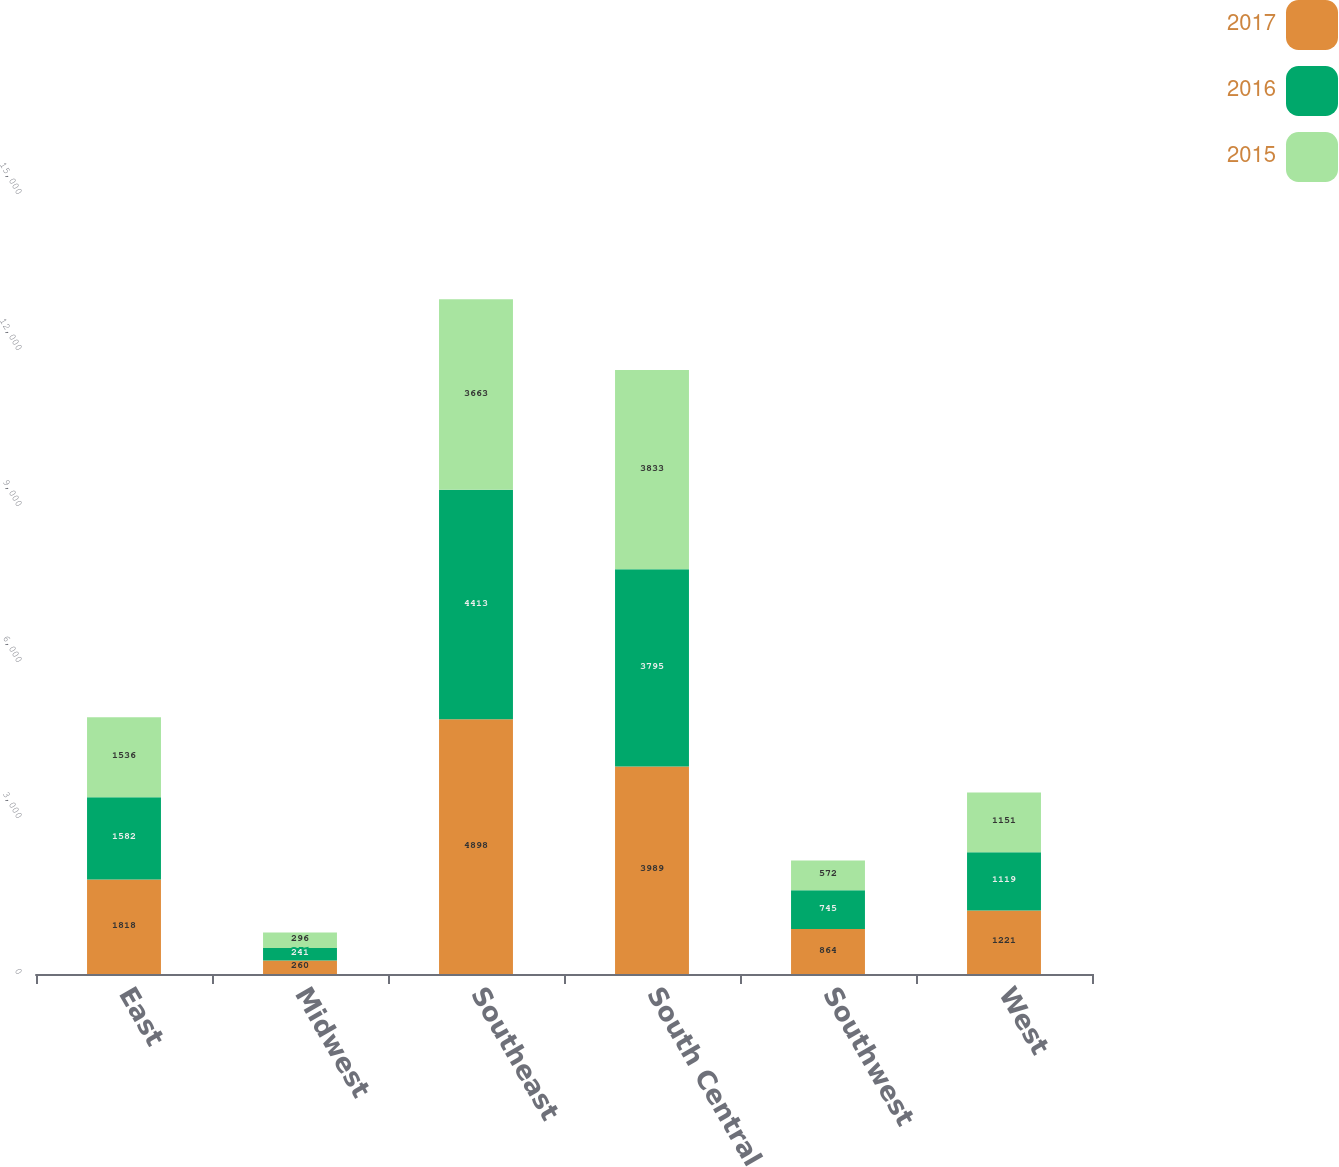Convert chart. <chart><loc_0><loc_0><loc_500><loc_500><stacked_bar_chart><ecel><fcel>East<fcel>Midwest<fcel>Southeast<fcel>South Central<fcel>Southwest<fcel>West<nl><fcel>2017<fcel>1818<fcel>260<fcel>4898<fcel>3989<fcel>864<fcel>1221<nl><fcel>2016<fcel>1582<fcel>241<fcel>4413<fcel>3795<fcel>745<fcel>1119<nl><fcel>2015<fcel>1536<fcel>296<fcel>3663<fcel>3833<fcel>572<fcel>1151<nl></chart> 